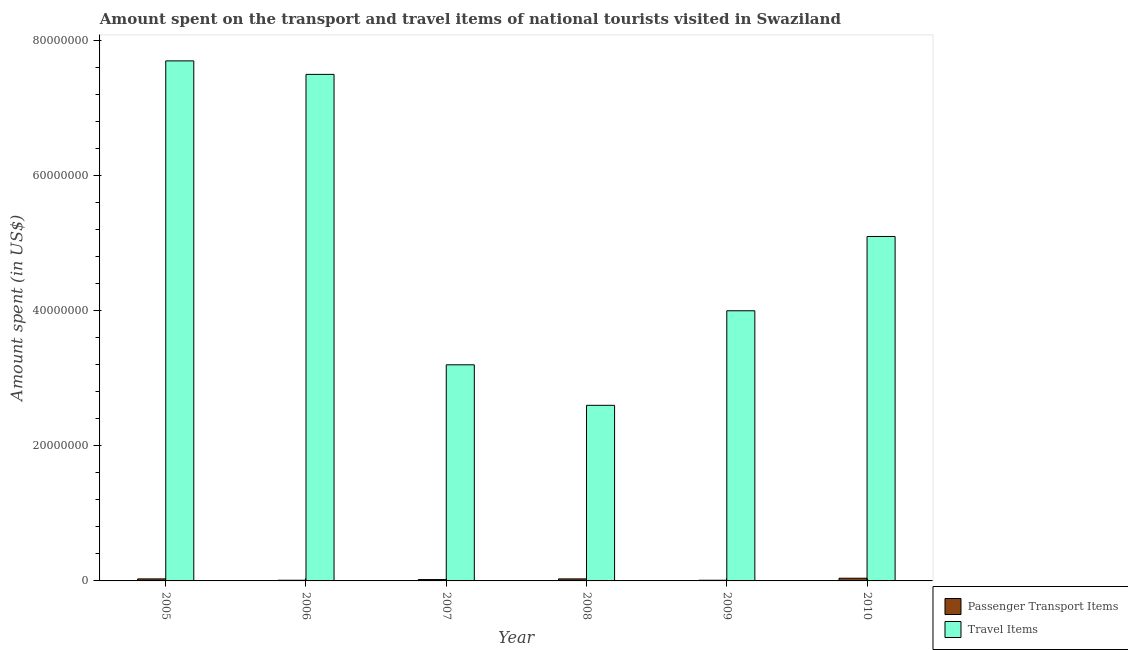How many groups of bars are there?
Your answer should be compact. 6. Are the number of bars per tick equal to the number of legend labels?
Give a very brief answer. Yes. What is the amount spent on passenger transport items in 2010?
Provide a short and direct response. 4.00e+05. Across all years, what is the maximum amount spent in travel items?
Provide a short and direct response. 7.70e+07. Across all years, what is the minimum amount spent in travel items?
Your response must be concise. 2.60e+07. In which year was the amount spent in travel items minimum?
Make the answer very short. 2008. What is the total amount spent on passenger transport items in the graph?
Provide a succinct answer. 1.40e+06. What is the difference between the amount spent on passenger transport items in 2009 and the amount spent in travel items in 2007?
Provide a short and direct response. -1.00e+05. What is the average amount spent on passenger transport items per year?
Ensure brevity in your answer.  2.33e+05. What is the ratio of the amount spent in travel items in 2006 to that in 2009?
Make the answer very short. 1.88. Is the amount spent in travel items in 2009 less than that in 2010?
Your response must be concise. Yes. What is the difference between the highest and the second highest amount spent in travel items?
Give a very brief answer. 2.00e+06. What is the difference between the highest and the lowest amount spent in travel items?
Provide a short and direct response. 5.10e+07. In how many years, is the amount spent on passenger transport items greater than the average amount spent on passenger transport items taken over all years?
Offer a terse response. 3. Is the sum of the amount spent on passenger transport items in 2006 and 2010 greater than the maximum amount spent in travel items across all years?
Your answer should be compact. Yes. What does the 2nd bar from the left in 2007 represents?
Offer a terse response. Travel Items. What does the 1st bar from the right in 2005 represents?
Give a very brief answer. Travel Items. How many bars are there?
Provide a short and direct response. 12. What is the difference between two consecutive major ticks on the Y-axis?
Keep it short and to the point. 2.00e+07. Are the values on the major ticks of Y-axis written in scientific E-notation?
Your answer should be compact. No. How are the legend labels stacked?
Offer a very short reply. Vertical. What is the title of the graph?
Your answer should be compact. Amount spent on the transport and travel items of national tourists visited in Swaziland. What is the label or title of the X-axis?
Keep it short and to the point. Year. What is the label or title of the Y-axis?
Make the answer very short. Amount spent (in US$). What is the Amount spent (in US$) in Passenger Transport Items in 2005?
Offer a very short reply. 3.00e+05. What is the Amount spent (in US$) in Travel Items in 2005?
Keep it short and to the point. 7.70e+07. What is the Amount spent (in US$) of Travel Items in 2006?
Ensure brevity in your answer.  7.50e+07. What is the Amount spent (in US$) in Travel Items in 2007?
Provide a short and direct response. 3.20e+07. What is the Amount spent (in US$) of Travel Items in 2008?
Ensure brevity in your answer.  2.60e+07. What is the Amount spent (in US$) in Passenger Transport Items in 2009?
Your response must be concise. 1.00e+05. What is the Amount spent (in US$) of Travel Items in 2009?
Offer a terse response. 4.00e+07. What is the Amount spent (in US$) of Passenger Transport Items in 2010?
Ensure brevity in your answer.  4.00e+05. What is the Amount spent (in US$) in Travel Items in 2010?
Your answer should be very brief. 5.10e+07. Across all years, what is the maximum Amount spent (in US$) in Passenger Transport Items?
Keep it short and to the point. 4.00e+05. Across all years, what is the maximum Amount spent (in US$) in Travel Items?
Provide a succinct answer. 7.70e+07. Across all years, what is the minimum Amount spent (in US$) in Travel Items?
Your response must be concise. 2.60e+07. What is the total Amount spent (in US$) of Passenger Transport Items in the graph?
Your answer should be very brief. 1.40e+06. What is the total Amount spent (in US$) in Travel Items in the graph?
Keep it short and to the point. 3.01e+08. What is the difference between the Amount spent (in US$) in Travel Items in 2005 and that in 2006?
Your answer should be very brief. 2.00e+06. What is the difference between the Amount spent (in US$) of Travel Items in 2005 and that in 2007?
Your response must be concise. 4.50e+07. What is the difference between the Amount spent (in US$) of Travel Items in 2005 and that in 2008?
Keep it short and to the point. 5.10e+07. What is the difference between the Amount spent (in US$) of Travel Items in 2005 and that in 2009?
Keep it short and to the point. 3.70e+07. What is the difference between the Amount spent (in US$) of Passenger Transport Items in 2005 and that in 2010?
Give a very brief answer. -1.00e+05. What is the difference between the Amount spent (in US$) in Travel Items in 2005 and that in 2010?
Your answer should be very brief. 2.60e+07. What is the difference between the Amount spent (in US$) in Passenger Transport Items in 2006 and that in 2007?
Your answer should be very brief. -1.00e+05. What is the difference between the Amount spent (in US$) in Travel Items in 2006 and that in 2007?
Offer a terse response. 4.30e+07. What is the difference between the Amount spent (in US$) of Travel Items in 2006 and that in 2008?
Offer a very short reply. 4.90e+07. What is the difference between the Amount spent (in US$) of Travel Items in 2006 and that in 2009?
Provide a short and direct response. 3.50e+07. What is the difference between the Amount spent (in US$) in Travel Items in 2006 and that in 2010?
Offer a very short reply. 2.40e+07. What is the difference between the Amount spent (in US$) of Passenger Transport Items in 2007 and that in 2008?
Your response must be concise. -1.00e+05. What is the difference between the Amount spent (in US$) of Travel Items in 2007 and that in 2008?
Offer a terse response. 6.00e+06. What is the difference between the Amount spent (in US$) of Passenger Transport Items in 2007 and that in 2009?
Your answer should be compact. 1.00e+05. What is the difference between the Amount spent (in US$) of Travel Items in 2007 and that in 2009?
Provide a short and direct response. -8.00e+06. What is the difference between the Amount spent (in US$) of Passenger Transport Items in 2007 and that in 2010?
Provide a succinct answer. -2.00e+05. What is the difference between the Amount spent (in US$) of Travel Items in 2007 and that in 2010?
Ensure brevity in your answer.  -1.90e+07. What is the difference between the Amount spent (in US$) in Travel Items in 2008 and that in 2009?
Make the answer very short. -1.40e+07. What is the difference between the Amount spent (in US$) of Passenger Transport Items in 2008 and that in 2010?
Keep it short and to the point. -1.00e+05. What is the difference between the Amount spent (in US$) in Travel Items in 2008 and that in 2010?
Keep it short and to the point. -2.50e+07. What is the difference between the Amount spent (in US$) of Passenger Transport Items in 2009 and that in 2010?
Give a very brief answer. -3.00e+05. What is the difference between the Amount spent (in US$) of Travel Items in 2009 and that in 2010?
Make the answer very short. -1.10e+07. What is the difference between the Amount spent (in US$) of Passenger Transport Items in 2005 and the Amount spent (in US$) of Travel Items in 2006?
Keep it short and to the point. -7.47e+07. What is the difference between the Amount spent (in US$) of Passenger Transport Items in 2005 and the Amount spent (in US$) of Travel Items in 2007?
Ensure brevity in your answer.  -3.17e+07. What is the difference between the Amount spent (in US$) in Passenger Transport Items in 2005 and the Amount spent (in US$) in Travel Items in 2008?
Offer a very short reply. -2.57e+07. What is the difference between the Amount spent (in US$) of Passenger Transport Items in 2005 and the Amount spent (in US$) of Travel Items in 2009?
Your response must be concise. -3.97e+07. What is the difference between the Amount spent (in US$) in Passenger Transport Items in 2005 and the Amount spent (in US$) in Travel Items in 2010?
Your answer should be very brief. -5.07e+07. What is the difference between the Amount spent (in US$) of Passenger Transport Items in 2006 and the Amount spent (in US$) of Travel Items in 2007?
Provide a short and direct response. -3.19e+07. What is the difference between the Amount spent (in US$) in Passenger Transport Items in 2006 and the Amount spent (in US$) in Travel Items in 2008?
Provide a succinct answer. -2.59e+07. What is the difference between the Amount spent (in US$) of Passenger Transport Items in 2006 and the Amount spent (in US$) of Travel Items in 2009?
Provide a succinct answer. -3.99e+07. What is the difference between the Amount spent (in US$) of Passenger Transport Items in 2006 and the Amount spent (in US$) of Travel Items in 2010?
Keep it short and to the point. -5.09e+07. What is the difference between the Amount spent (in US$) of Passenger Transport Items in 2007 and the Amount spent (in US$) of Travel Items in 2008?
Give a very brief answer. -2.58e+07. What is the difference between the Amount spent (in US$) of Passenger Transport Items in 2007 and the Amount spent (in US$) of Travel Items in 2009?
Provide a short and direct response. -3.98e+07. What is the difference between the Amount spent (in US$) in Passenger Transport Items in 2007 and the Amount spent (in US$) in Travel Items in 2010?
Provide a short and direct response. -5.08e+07. What is the difference between the Amount spent (in US$) in Passenger Transport Items in 2008 and the Amount spent (in US$) in Travel Items in 2009?
Keep it short and to the point. -3.97e+07. What is the difference between the Amount spent (in US$) of Passenger Transport Items in 2008 and the Amount spent (in US$) of Travel Items in 2010?
Provide a short and direct response. -5.07e+07. What is the difference between the Amount spent (in US$) in Passenger Transport Items in 2009 and the Amount spent (in US$) in Travel Items in 2010?
Make the answer very short. -5.09e+07. What is the average Amount spent (in US$) in Passenger Transport Items per year?
Make the answer very short. 2.33e+05. What is the average Amount spent (in US$) of Travel Items per year?
Keep it short and to the point. 5.02e+07. In the year 2005, what is the difference between the Amount spent (in US$) in Passenger Transport Items and Amount spent (in US$) in Travel Items?
Offer a very short reply. -7.67e+07. In the year 2006, what is the difference between the Amount spent (in US$) of Passenger Transport Items and Amount spent (in US$) of Travel Items?
Keep it short and to the point. -7.49e+07. In the year 2007, what is the difference between the Amount spent (in US$) of Passenger Transport Items and Amount spent (in US$) of Travel Items?
Ensure brevity in your answer.  -3.18e+07. In the year 2008, what is the difference between the Amount spent (in US$) in Passenger Transport Items and Amount spent (in US$) in Travel Items?
Provide a short and direct response. -2.57e+07. In the year 2009, what is the difference between the Amount spent (in US$) in Passenger Transport Items and Amount spent (in US$) in Travel Items?
Provide a succinct answer. -3.99e+07. In the year 2010, what is the difference between the Amount spent (in US$) in Passenger Transport Items and Amount spent (in US$) in Travel Items?
Give a very brief answer. -5.06e+07. What is the ratio of the Amount spent (in US$) of Passenger Transport Items in 2005 to that in 2006?
Your answer should be compact. 3. What is the ratio of the Amount spent (in US$) of Travel Items in 2005 to that in 2006?
Provide a succinct answer. 1.03. What is the ratio of the Amount spent (in US$) of Travel Items in 2005 to that in 2007?
Make the answer very short. 2.41. What is the ratio of the Amount spent (in US$) in Travel Items in 2005 to that in 2008?
Offer a very short reply. 2.96. What is the ratio of the Amount spent (in US$) in Travel Items in 2005 to that in 2009?
Your answer should be compact. 1.93. What is the ratio of the Amount spent (in US$) of Travel Items in 2005 to that in 2010?
Your response must be concise. 1.51. What is the ratio of the Amount spent (in US$) of Passenger Transport Items in 2006 to that in 2007?
Your answer should be compact. 0.5. What is the ratio of the Amount spent (in US$) of Travel Items in 2006 to that in 2007?
Offer a very short reply. 2.34. What is the ratio of the Amount spent (in US$) in Travel Items in 2006 to that in 2008?
Ensure brevity in your answer.  2.88. What is the ratio of the Amount spent (in US$) of Travel Items in 2006 to that in 2009?
Give a very brief answer. 1.88. What is the ratio of the Amount spent (in US$) in Travel Items in 2006 to that in 2010?
Your answer should be compact. 1.47. What is the ratio of the Amount spent (in US$) of Passenger Transport Items in 2007 to that in 2008?
Your answer should be very brief. 0.67. What is the ratio of the Amount spent (in US$) in Travel Items in 2007 to that in 2008?
Your answer should be very brief. 1.23. What is the ratio of the Amount spent (in US$) in Travel Items in 2007 to that in 2009?
Your answer should be compact. 0.8. What is the ratio of the Amount spent (in US$) of Passenger Transport Items in 2007 to that in 2010?
Make the answer very short. 0.5. What is the ratio of the Amount spent (in US$) of Travel Items in 2007 to that in 2010?
Your answer should be compact. 0.63. What is the ratio of the Amount spent (in US$) in Passenger Transport Items in 2008 to that in 2009?
Your response must be concise. 3. What is the ratio of the Amount spent (in US$) of Travel Items in 2008 to that in 2009?
Your answer should be compact. 0.65. What is the ratio of the Amount spent (in US$) of Travel Items in 2008 to that in 2010?
Your answer should be compact. 0.51. What is the ratio of the Amount spent (in US$) of Travel Items in 2009 to that in 2010?
Make the answer very short. 0.78. What is the difference between the highest and the second highest Amount spent (in US$) of Passenger Transport Items?
Provide a short and direct response. 1.00e+05. What is the difference between the highest and the second highest Amount spent (in US$) of Travel Items?
Give a very brief answer. 2.00e+06. What is the difference between the highest and the lowest Amount spent (in US$) in Passenger Transport Items?
Offer a terse response. 3.00e+05. What is the difference between the highest and the lowest Amount spent (in US$) in Travel Items?
Your response must be concise. 5.10e+07. 